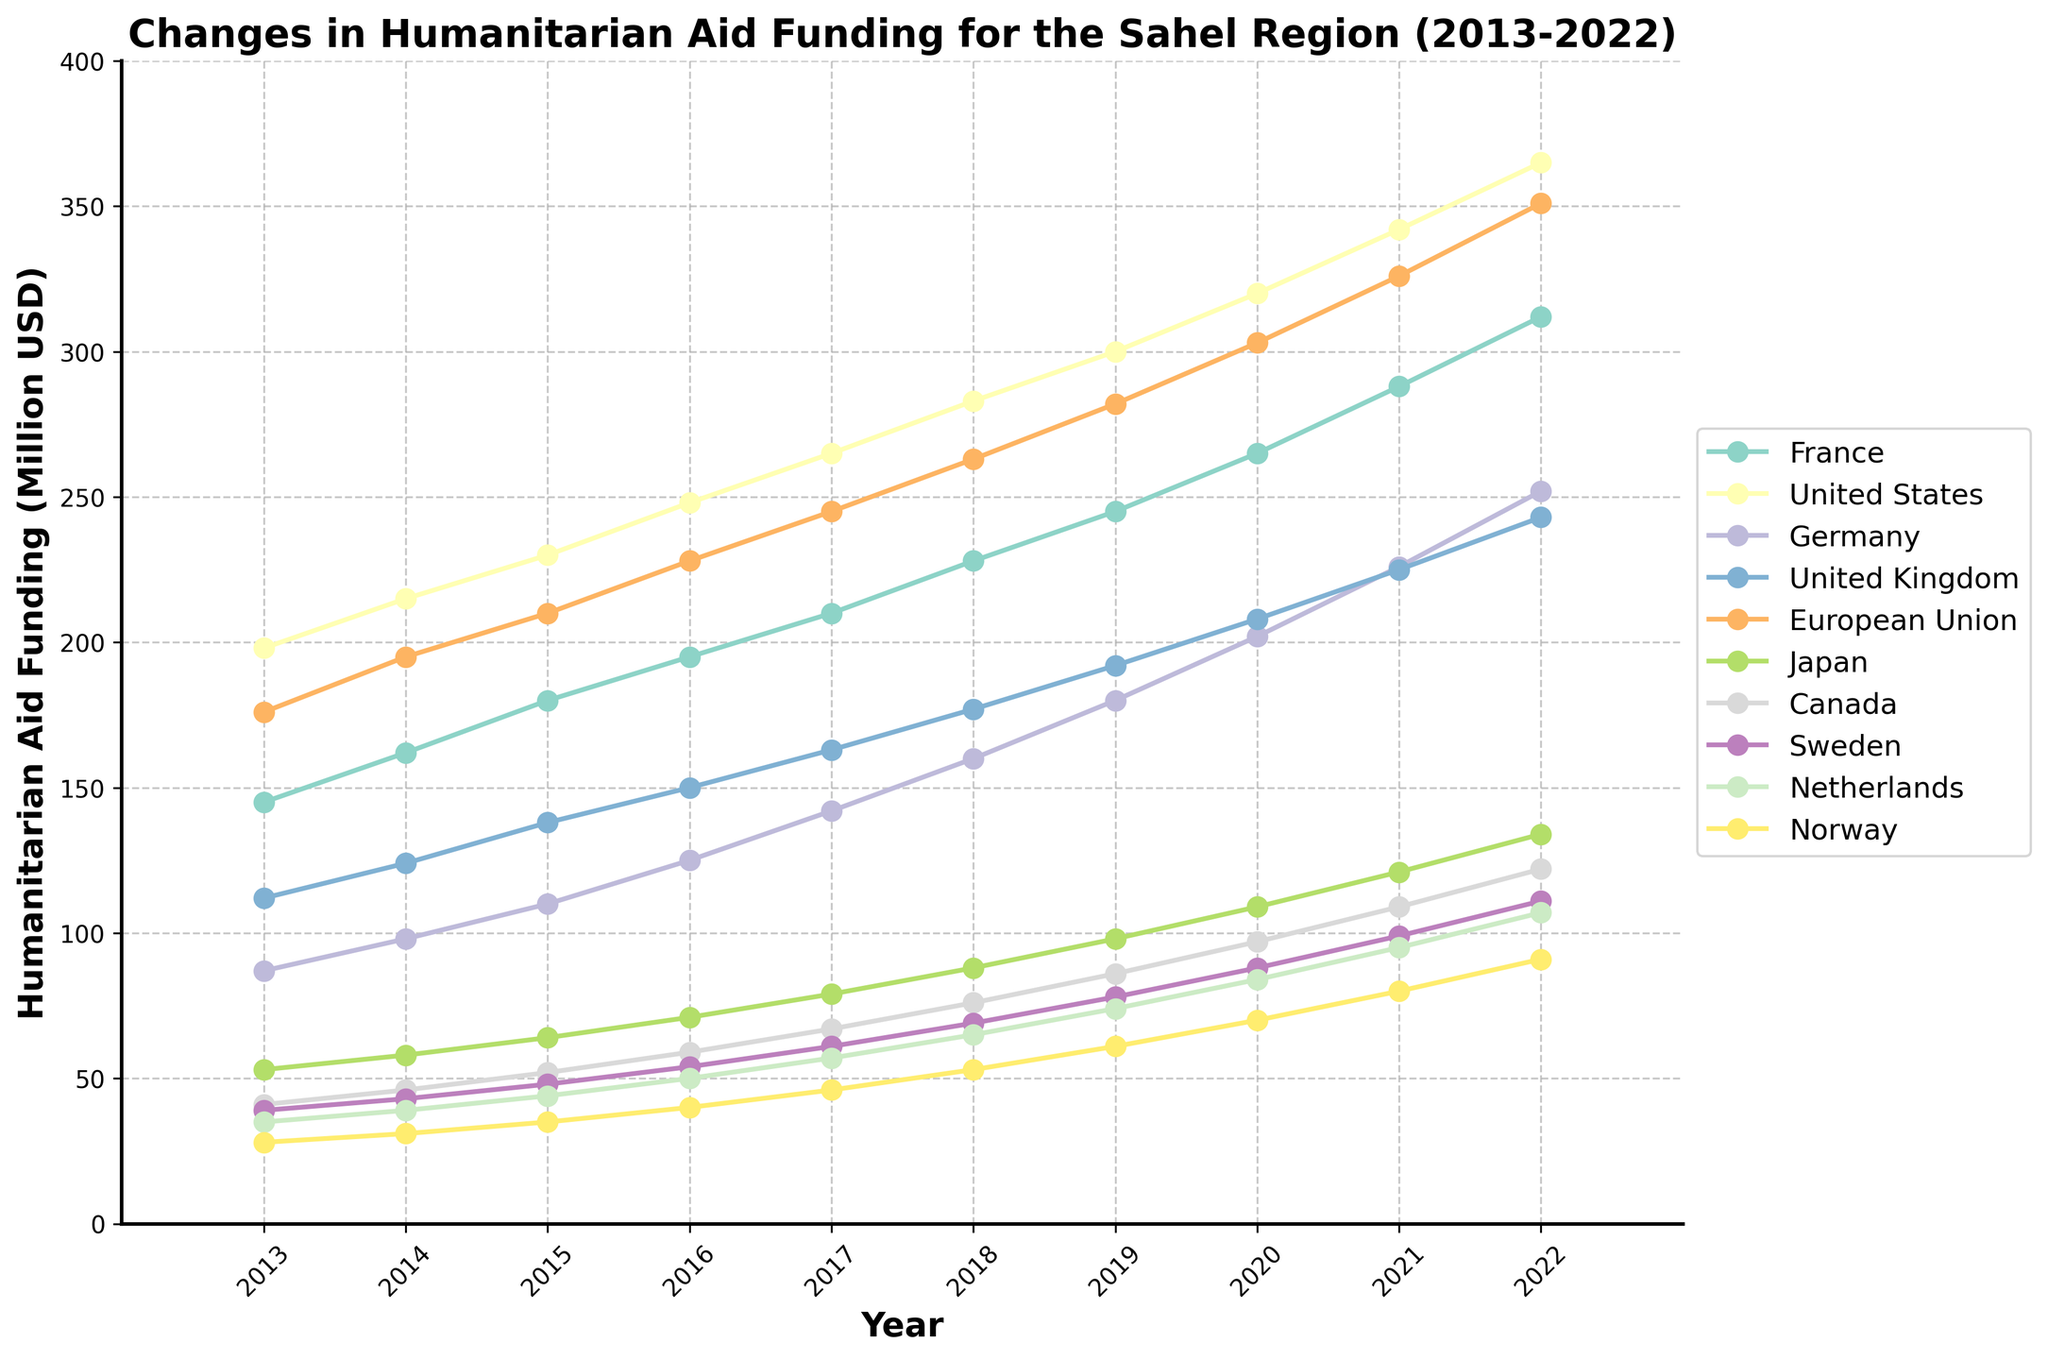What is the overall trend of humanitarian aid funding from the United States between 2013 and 2022? The aid funding from the United States shows a continuous increase over the years. It starts at 198 million USD in 2013 and reaches 365 million USD in 2022, indicating a steady rise.
Answer: Continuous increase Which donor country had the highest increase in humanitarian aid funding over the decade? Comparing the starting and ending values for each country, the United States had the highest increase. In 2013, its aid funding was 198 million USD, and by 2022 it increased to 365 million USD, a difference of 167 million USD.
Answer: United States In 2020, which country provided more humanitarian aid: Germany or the United Kingdom? In 2020, Germany provided 202 million USD, while the United Kingdom provided 208 million USD. Comparing these values shows that the United Kingdom provided more aid.
Answer: United Kingdom What's the average humanitarian aid funding from France over this period? Summing the values for France from 2013 to 2022 and then dividing by the number of years gives the average. (145 + 162 + 180 + 195 + 210 + 228 + 245 + 265 + 288 + 312) / 10 = 2230 / 10 = 223
Answer: 223 How does the aid funding from the European Union in 2013 compare to Japan's funding in 2022? In 2013, the European Union provided 176 million USD, while in 2022, Japan provided 134 million USD. The European Union's funding in 2013 is higher than Japan's funding in 2022.
Answer: European Union's funding in 2013 is higher For which year do we see the highest humanitarian aid funding from Canada? By inspecting the plot, the highest funding from Canada is in 2022, where it reaches 122 million USD.
Answer: 2022 What is the increase in aid funding from Sweden between 2018 and 2022? The funding from Sweden in 2018 was 69 million USD and in 2022 it was 111 million USD. The increase is 111 - 69 = 42 million USD.
Answer: 42 million USD How does the trend in humanitarian aid funding from Norway compare to that from the Netherlands over the years? Both countries show an increasing trend in aid funding. However, Norway's increase is relatively steadier and more gradual compared to the Netherlands, which also increases consistently over time but with slightly larger bumps.
Answer: Both increase, Norway steadier What is the total humanitarian aid funding provided by Germany and Canada together in 2020? Adding the funding from Germany (202 million USD) and Canada (97 million USD) for the year 2020 gives 202 + 97 = 299 million USD.
Answer: 299 million USD Which donor had the lowest total increase in aid funding from 2013 to 2022? By calculating the difference between the 2022 and 2013 funding for each donor, Japan shows the smallest increase (134 - 53 = 81 million USD).
Answer: Japan 